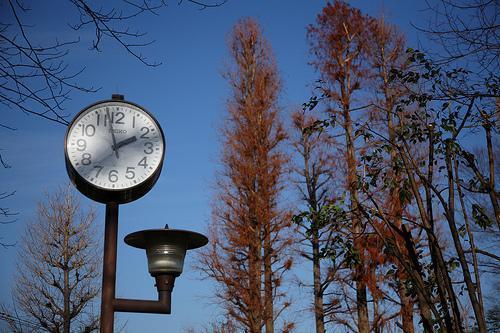How many clocks are shown?
Give a very brief answer. 1. How many numbers are on the clock?
Give a very brief answer. 12. 